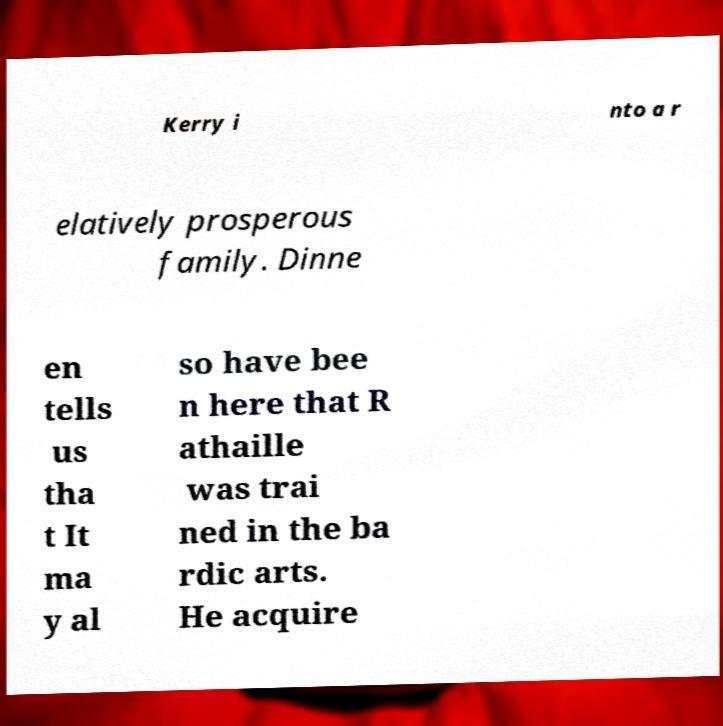Can you read and provide the text displayed in the image?This photo seems to have some interesting text. Can you extract and type it out for me? Kerry i nto a r elatively prosperous family. Dinne en tells us tha t It ma y al so have bee n here that R athaille was trai ned in the ba rdic arts. He acquire 